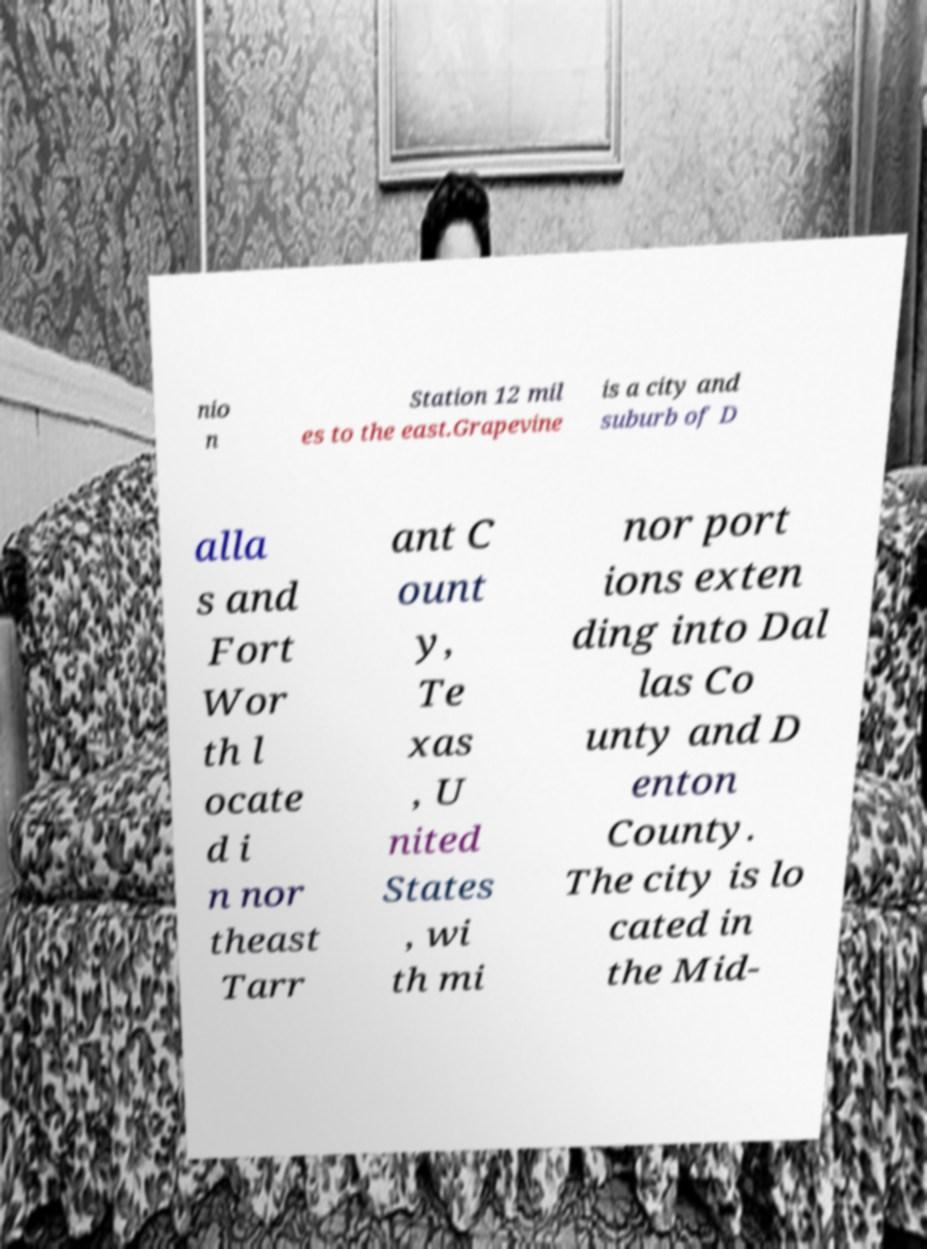Can you accurately transcribe the text from the provided image for me? nio n Station 12 mil es to the east.Grapevine is a city and suburb of D alla s and Fort Wor th l ocate d i n nor theast Tarr ant C ount y, Te xas , U nited States , wi th mi nor port ions exten ding into Dal las Co unty and D enton County. The city is lo cated in the Mid- 